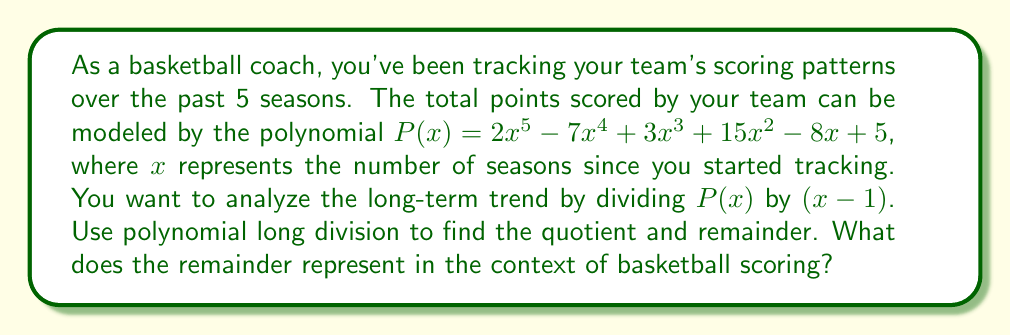Give your solution to this math problem. Let's perform polynomial long division of $P(x)$ by $(x - 1)$:

$$
\begin{array}{r}
2x^4 - 5x^3 - 2x^2 + 13x + 5 \\
x - 1 \enclose{longdiv}{2x^5 - 7x^4 + 3x^3 + 15x^2 - 8x + 5} \\
\underline{2x^5 - 2x^4} \\
-5x^4 + 3x^3 \\
\underline{-5x^4 + 5x^3} \\
-2x^3 + 15x^2 \\
\underline{-2x^3 + 2x^2} \\
13x^2 - 8x \\
\underline{13x^2 - 13x} \\
5x + 5 \\
\underline{5x - 5} \\
10
\end{array}
$$

The quotient is $2x^4 - 5x^3 - 2x^2 + 13x + 5$ and the remainder is 10.

In the context of basketball scoring:
1. The quotient represents the general trend of scoring over time, showing how the team's performance changes across seasons.
2. The remainder of 10 represents the constant difference between the actual scoring pattern and the trend line.
3. This constant difference of 10 points suggests that the team consistently scores 10 points more than what the trend line predicts each season.
4. As a coach, this information is valuable as it indicates a consistent over-performance relative to the expected trend, which could be attributed to factors like consistent training methods or team culture.
Answer: The remainder is 10, which represents a constant 10-point over-performance in the team's scoring compared to the predicted trend line each season. 